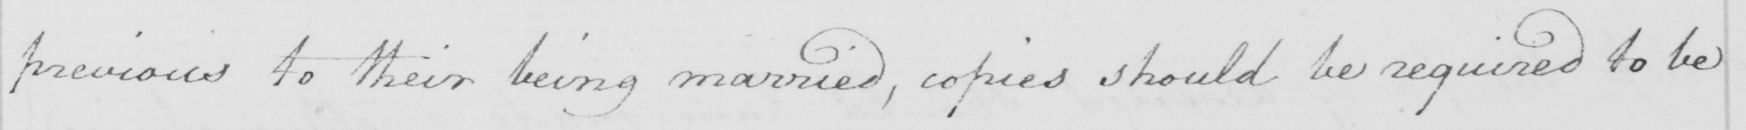Please provide the text content of this handwritten line. previous to their being married, copies should be required to be 